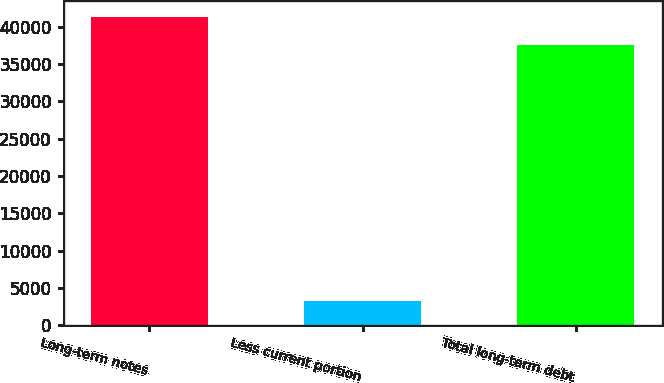<chart> <loc_0><loc_0><loc_500><loc_500><bar_chart><fcel>Long-term notes<fcel>Less current portion<fcel>Total long-term debt<nl><fcel>41398.5<fcel>3188<fcel>37635<nl></chart> 